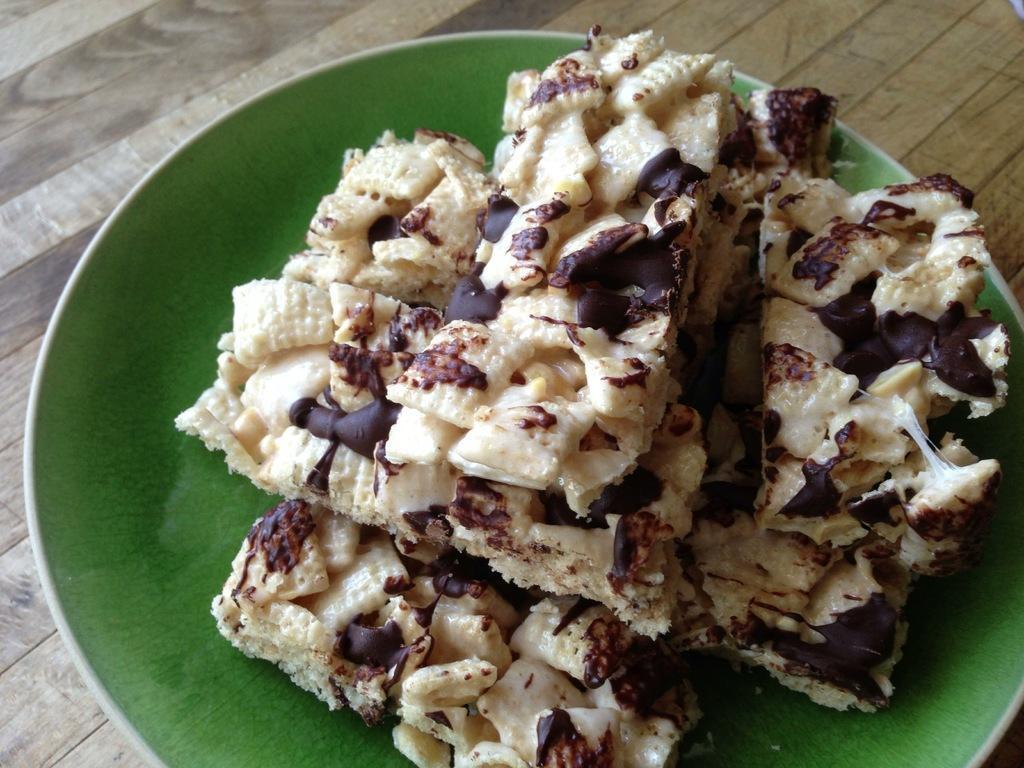Please provide a concise description of this image. In this image there is a table, on that table there is a plate, in that place there is a food item. 